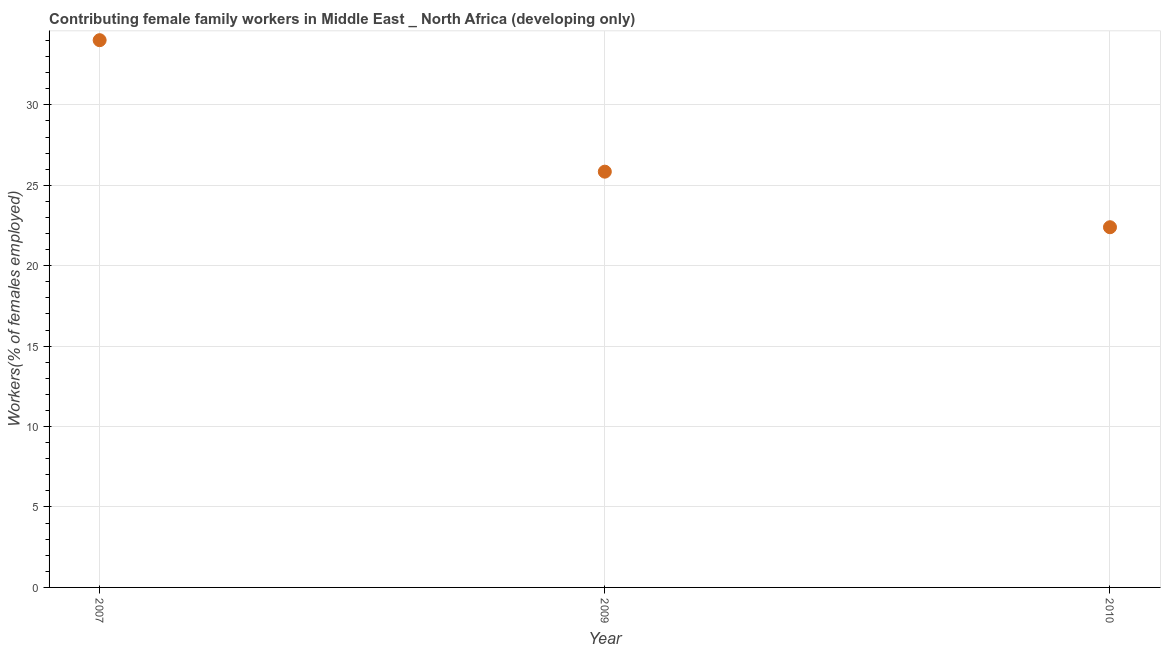What is the contributing female family workers in 2009?
Give a very brief answer. 25.85. Across all years, what is the maximum contributing female family workers?
Offer a very short reply. 34.02. Across all years, what is the minimum contributing female family workers?
Your response must be concise. 22.39. What is the sum of the contributing female family workers?
Your answer should be compact. 82.26. What is the difference between the contributing female family workers in 2009 and 2010?
Your answer should be compact. 3.45. What is the average contributing female family workers per year?
Keep it short and to the point. 27.42. What is the median contributing female family workers?
Make the answer very short. 25.85. Do a majority of the years between 2009 and 2010 (inclusive) have contributing female family workers greater than 23 %?
Offer a terse response. No. What is the ratio of the contributing female family workers in 2007 to that in 2009?
Keep it short and to the point. 1.32. What is the difference between the highest and the second highest contributing female family workers?
Your answer should be compact. 8.17. Is the sum of the contributing female family workers in 2009 and 2010 greater than the maximum contributing female family workers across all years?
Offer a very short reply. Yes. What is the difference between the highest and the lowest contributing female family workers?
Offer a terse response. 11.63. Does the contributing female family workers monotonically increase over the years?
Ensure brevity in your answer.  No. How many dotlines are there?
Your answer should be very brief. 1. How many years are there in the graph?
Your answer should be very brief. 3. Does the graph contain any zero values?
Offer a very short reply. No. Does the graph contain grids?
Provide a short and direct response. Yes. What is the title of the graph?
Your answer should be very brief. Contributing female family workers in Middle East _ North Africa (developing only). What is the label or title of the Y-axis?
Your answer should be very brief. Workers(% of females employed). What is the Workers(% of females employed) in 2007?
Offer a very short reply. 34.02. What is the Workers(% of females employed) in 2009?
Provide a short and direct response. 25.85. What is the Workers(% of females employed) in 2010?
Offer a terse response. 22.39. What is the difference between the Workers(% of females employed) in 2007 and 2009?
Keep it short and to the point. 8.17. What is the difference between the Workers(% of females employed) in 2007 and 2010?
Make the answer very short. 11.63. What is the difference between the Workers(% of females employed) in 2009 and 2010?
Offer a terse response. 3.45. What is the ratio of the Workers(% of females employed) in 2007 to that in 2009?
Offer a terse response. 1.32. What is the ratio of the Workers(% of females employed) in 2007 to that in 2010?
Your response must be concise. 1.52. What is the ratio of the Workers(% of females employed) in 2009 to that in 2010?
Your answer should be compact. 1.15. 